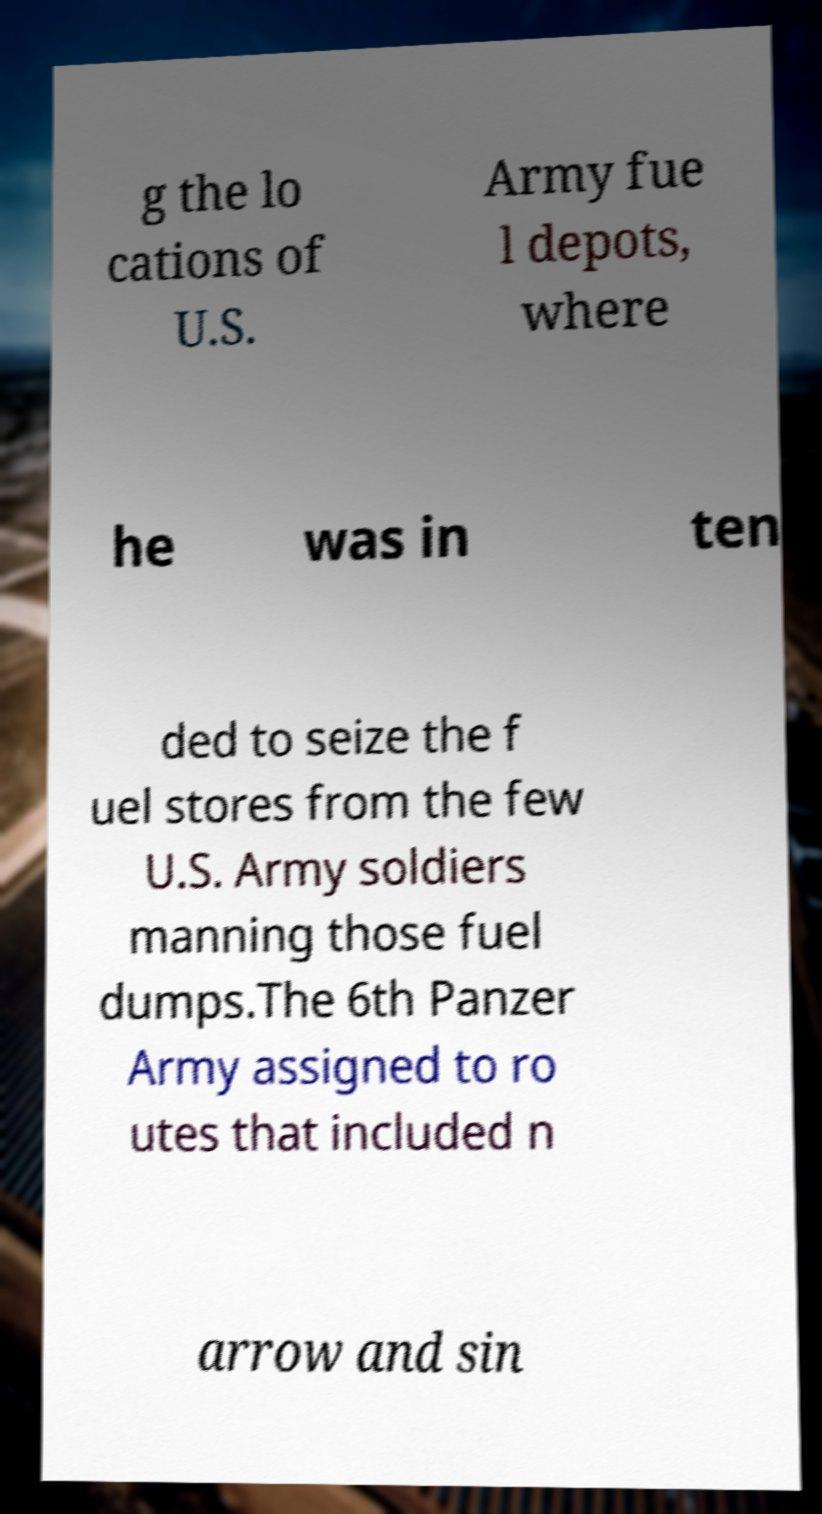Please identify and transcribe the text found in this image. g the lo cations of U.S. Army fue l depots, where he was in ten ded to seize the f uel stores from the few U.S. Army soldiers manning those fuel dumps.The 6th Panzer Army assigned to ro utes that included n arrow and sin 